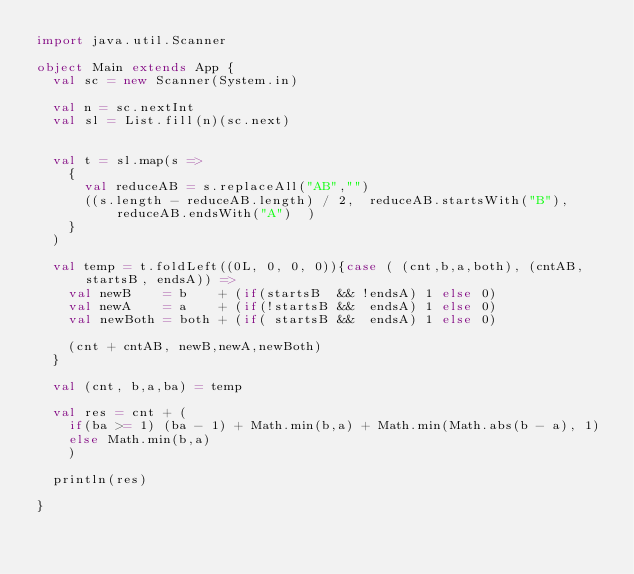<code> <loc_0><loc_0><loc_500><loc_500><_Scala_>import java.util.Scanner

object Main extends App {
  val sc = new Scanner(System.in)

  val n = sc.nextInt
  val sl = List.fill(n)(sc.next)


  val t = sl.map(s =>
    {
      val reduceAB = s.replaceAll("AB","")
      ((s.length - reduceAB.length) / 2,  reduceAB.startsWith("B"), reduceAB.endsWith("A")  )
    }
  )

  val temp = t.foldLeft((0L, 0, 0, 0)){case ( (cnt,b,a,both), (cntAB, startsB, endsA)) =>
    val newB    = b    + (if(startsB  && !endsA) 1 else 0)
    val newA    = a    + (if(!startsB &&  endsA) 1 else 0)
    val newBoth = both + (if( startsB &&  endsA) 1 else 0)

    (cnt + cntAB, newB,newA,newBoth)
  }

  val (cnt, b,a,ba) = temp
  
  val res = cnt + (
    if(ba >= 1) (ba - 1) + Math.min(b,a) + Math.min(Math.abs(b - a), 1)
    else Math.min(b,a)
    )

  println(res)

}</code> 